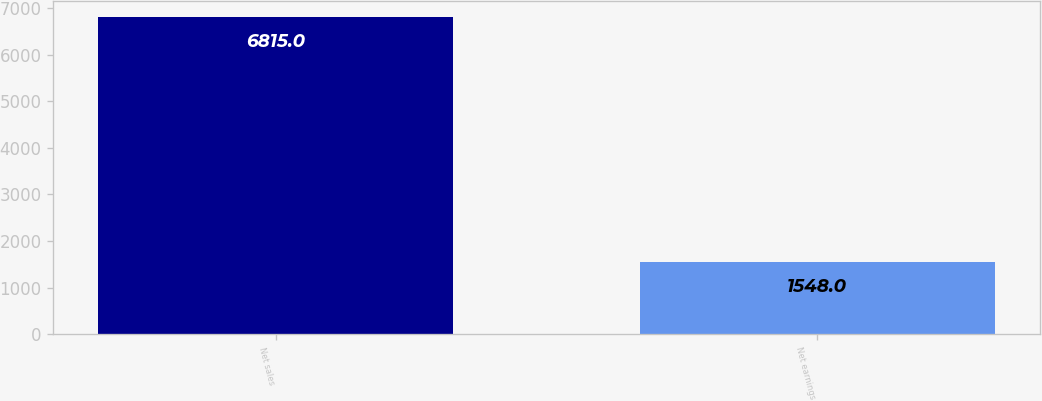Convert chart. <chart><loc_0><loc_0><loc_500><loc_500><bar_chart><fcel>Net sales<fcel>Net earnings<nl><fcel>6815<fcel>1548<nl></chart> 